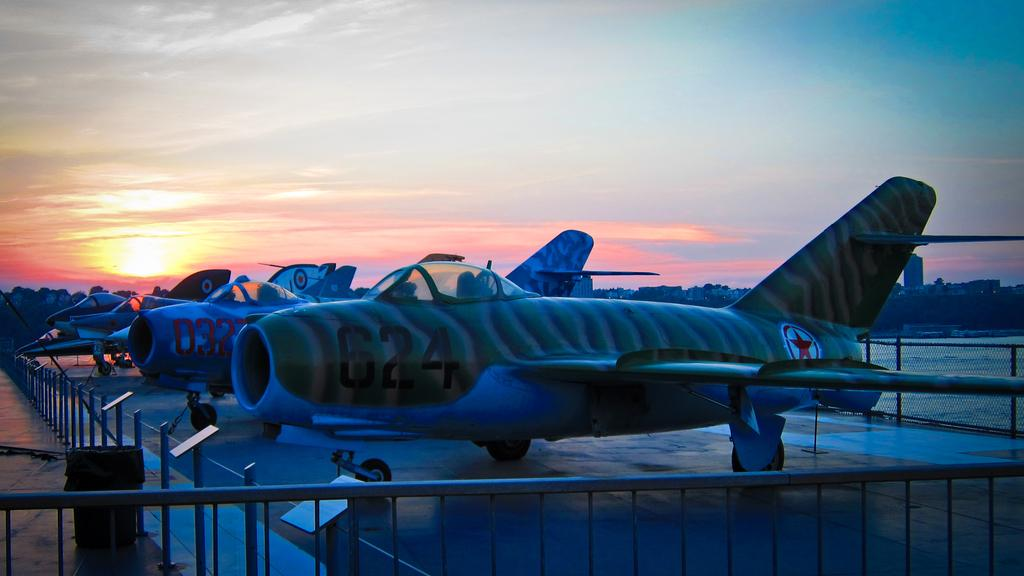<image>
Render a clear and concise summary of the photo. The identifying number of the first airplane is 624. 